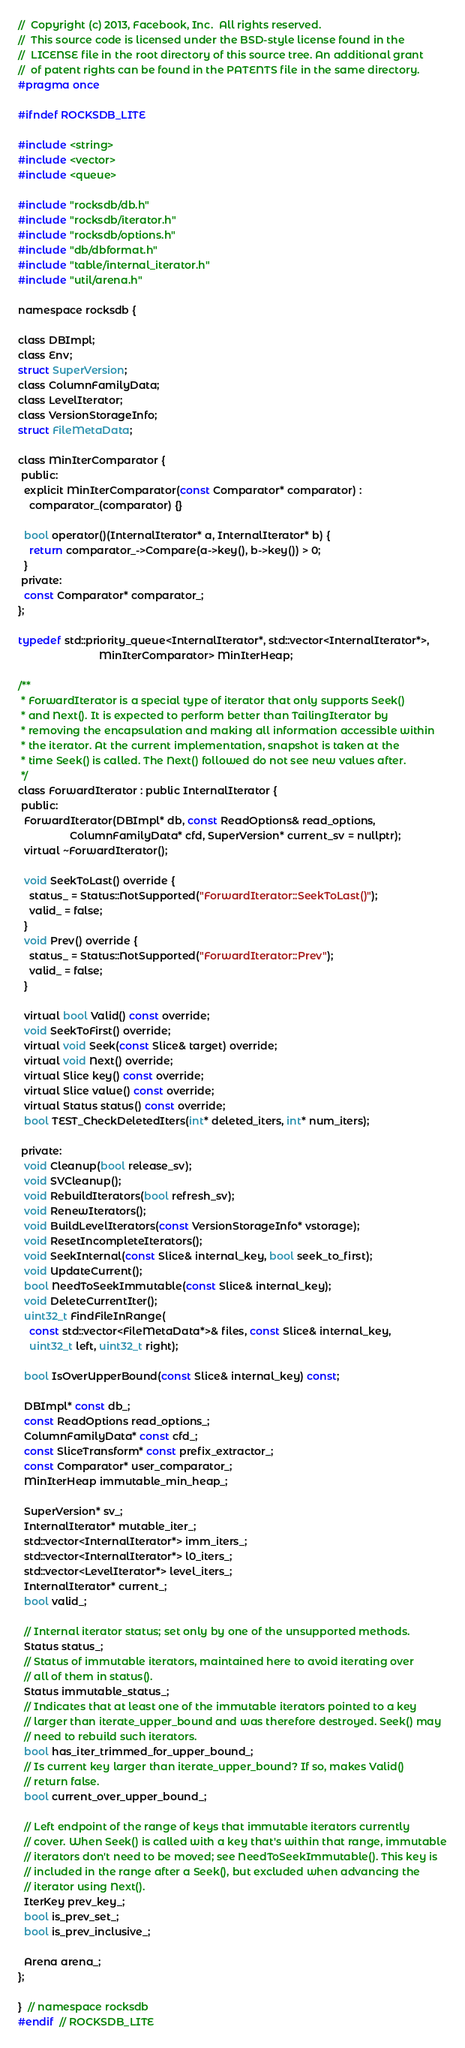Convert code to text. <code><loc_0><loc_0><loc_500><loc_500><_C_>//  Copyright (c) 2013, Facebook, Inc.  All rights reserved.
//  This source code is licensed under the BSD-style license found in the
//  LICENSE file in the root directory of this source tree. An additional grant
//  of patent rights can be found in the PATENTS file in the same directory.
#pragma once

#ifndef ROCKSDB_LITE

#include <string>
#include <vector>
#include <queue>

#include "rocksdb/db.h"
#include "rocksdb/iterator.h"
#include "rocksdb/options.h"
#include "db/dbformat.h"
#include "table/internal_iterator.h"
#include "util/arena.h"

namespace rocksdb {

class DBImpl;
class Env;
struct SuperVersion;
class ColumnFamilyData;
class LevelIterator;
class VersionStorageInfo;
struct FileMetaData;

class MinIterComparator {
 public:
  explicit MinIterComparator(const Comparator* comparator) :
    comparator_(comparator) {}

  bool operator()(InternalIterator* a, InternalIterator* b) {
    return comparator_->Compare(a->key(), b->key()) > 0;
  }
 private:
  const Comparator* comparator_;
};

typedef std::priority_queue<InternalIterator*, std::vector<InternalIterator*>,
                            MinIterComparator> MinIterHeap;

/**
 * ForwardIterator is a special type of iterator that only supports Seek()
 * and Next(). It is expected to perform better than TailingIterator by
 * removing the encapsulation and making all information accessible within
 * the iterator. At the current implementation, snapshot is taken at the
 * time Seek() is called. The Next() followed do not see new values after.
 */
class ForwardIterator : public InternalIterator {
 public:
  ForwardIterator(DBImpl* db, const ReadOptions& read_options,
                  ColumnFamilyData* cfd, SuperVersion* current_sv = nullptr);
  virtual ~ForwardIterator();

  void SeekToLast() override {
    status_ = Status::NotSupported("ForwardIterator::SeekToLast()");
    valid_ = false;
  }
  void Prev() override {
    status_ = Status::NotSupported("ForwardIterator::Prev");
    valid_ = false;
  }

  virtual bool Valid() const override;
  void SeekToFirst() override;
  virtual void Seek(const Slice& target) override;
  virtual void Next() override;
  virtual Slice key() const override;
  virtual Slice value() const override;
  virtual Status status() const override;
  bool TEST_CheckDeletedIters(int* deleted_iters, int* num_iters);

 private:
  void Cleanup(bool release_sv);
  void SVCleanup();
  void RebuildIterators(bool refresh_sv);
  void RenewIterators();
  void BuildLevelIterators(const VersionStorageInfo* vstorage);
  void ResetIncompleteIterators();
  void SeekInternal(const Slice& internal_key, bool seek_to_first);
  void UpdateCurrent();
  bool NeedToSeekImmutable(const Slice& internal_key);
  void DeleteCurrentIter();
  uint32_t FindFileInRange(
    const std::vector<FileMetaData*>& files, const Slice& internal_key,
    uint32_t left, uint32_t right);

  bool IsOverUpperBound(const Slice& internal_key) const;

  DBImpl* const db_;
  const ReadOptions read_options_;
  ColumnFamilyData* const cfd_;
  const SliceTransform* const prefix_extractor_;
  const Comparator* user_comparator_;
  MinIterHeap immutable_min_heap_;

  SuperVersion* sv_;
  InternalIterator* mutable_iter_;
  std::vector<InternalIterator*> imm_iters_;
  std::vector<InternalIterator*> l0_iters_;
  std::vector<LevelIterator*> level_iters_;
  InternalIterator* current_;
  bool valid_;

  // Internal iterator status; set only by one of the unsupported methods.
  Status status_;
  // Status of immutable iterators, maintained here to avoid iterating over
  // all of them in status().
  Status immutable_status_;
  // Indicates that at least one of the immutable iterators pointed to a key
  // larger than iterate_upper_bound and was therefore destroyed. Seek() may
  // need to rebuild such iterators.
  bool has_iter_trimmed_for_upper_bound_;
  // Is current key larger than iterate_upper_bound? If so, makes Valid()
  // return false.
  bool current_over_upper_bound_;

  // Left endpoint of the range of keys that immutable iterators currently
  // cover. When Seek() is called with a key that's within that range, immutable
  // iterators don't need to be moved; see NeedToSeekImmutable(). This key is
  // included in the range after a Seek(), but excluded when advancing the
  // iterator using Next().
  IterKey prev_key_;
  bool is_prev_set_;
  bool is_prev_inclusive_;

  Arena arena_;
};

}  // namespace rocksdb
#endif  // ROCKSDB_LITE
</code> 